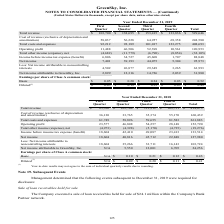According to Greensky's financial document, What was the cost of revenue in the fourth quarter? According to the financial document, 55,170 (in thousands). The relevant text states: "preciation and amortization) 36,130 33,765 35,374 55,170 160,439 Total costs and expenses 61,749 58,896 59,655 81,583 261,883 Operating profit 23,577 46,808..." Also, What was the total costs and expenses? According to the financial document, 261,883 (in thousands). The relevant text states: "al costs and expenses 61,749 58,896 59,655 81,583 261,883 Operating profit 23,577 46,808 54,257 28,148 152,790 Total other income (expense), net (4,973) (4,3..." Also, What was the net total other income (expense)? According to the financial document, (19,276) (in thousands). The relevant text states: "ome (expense), net (4,973) (4,398) (5,170) (4,735) (19,276) Income before income tax expense (benefit) 18,604 42,410 49,087 23,413 133,514 Net income 18,604 40,..." Also, How many quarters did basic earnings per share of Class A common stock exceed $0.20? Based on the analysis, there are 1 instances. The counting process: third quarter. Also, can you calculate: What was the change in total costs and expenses between the second and third quarter? Based on the calculation: 59,655-58,896, the result is 759 (in thousands). This is based on the information: "74 55,170 160,439 Total costs and expenses 61,749 58,896 59,655 81,583 261,883 Operating profit 23,577 46,808 54,257 28,148 152,790 Total other income (expe 70 160,439 Total costs and expenses 61,749 ..." The key data points involved are: 58,896, 59,655. Also, can you calculate: What was the percentage change in the net income between the third and fourth quarter? To answer this question, I need to perform calculations using the financial data. The calculation is: (22,848-45,712)/45,712, which equals -50.02 (percentage). This is based on the information: "10 49,087 23,413 133,514 Net income 18,604 40,816 45,712 22,848 127,980 Less: Net income attributable to noncontrolling interests 18,604 35,266 33,711 16,14 87 23,413 133,514 Net income 18,604 40,816 ..." The key data points involved are: 22,848, 45,712. 